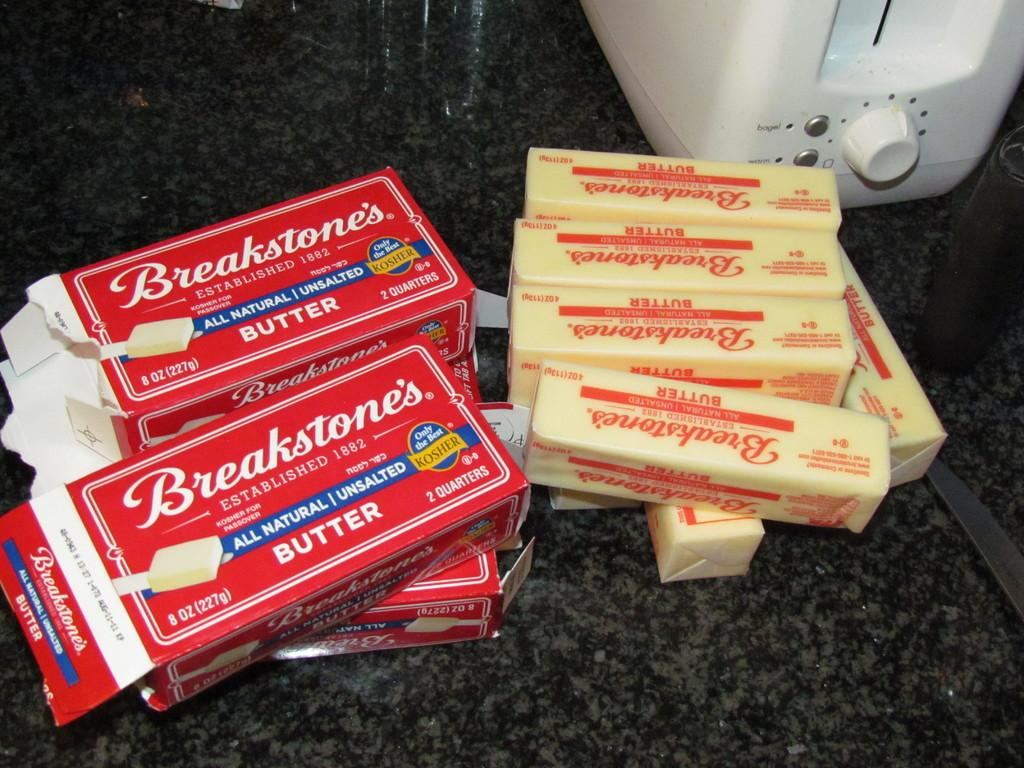<image>
Give a short and clear explanation of the subsequent image. several containers of breakstones butter is laying on the counter 